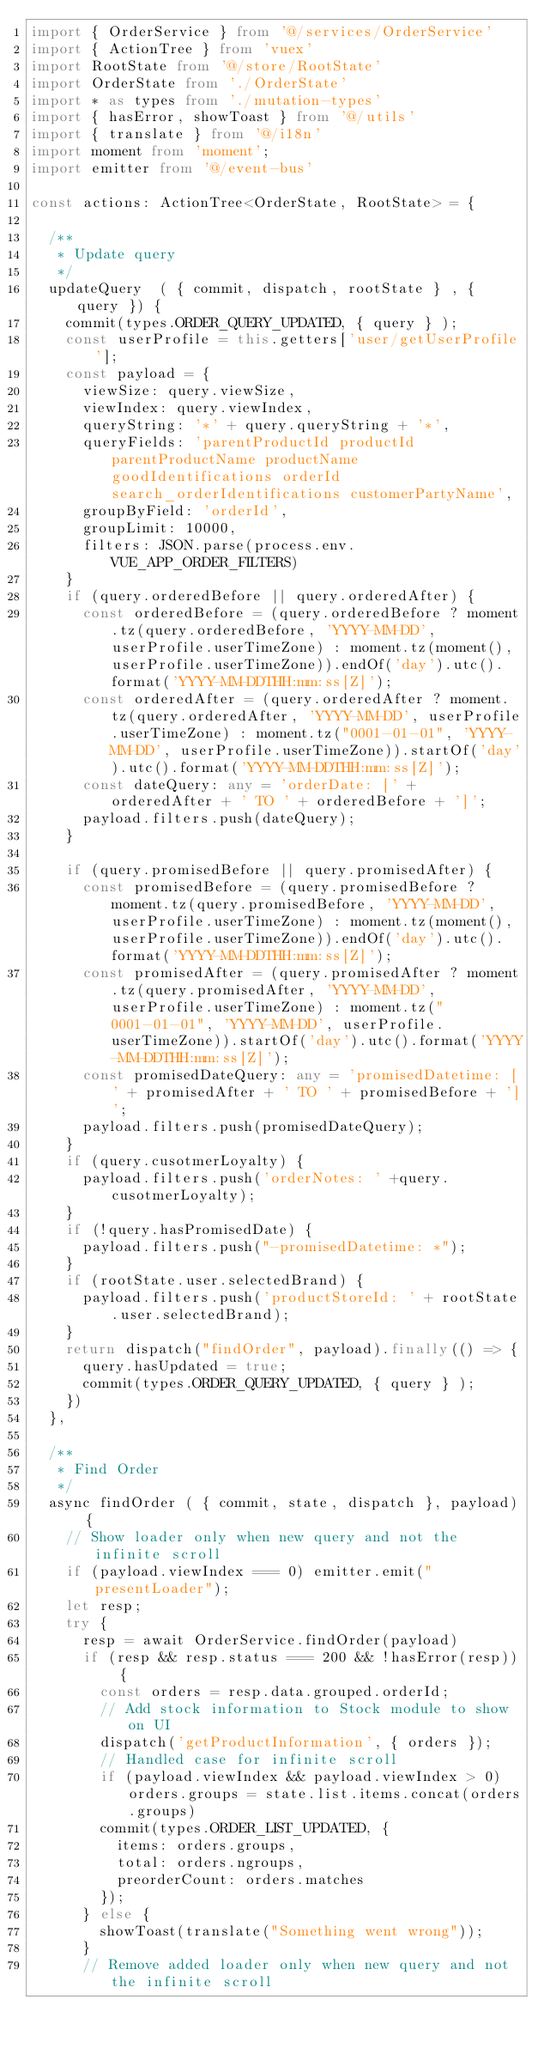<code> <loc_0><loc_0><loc_500><loc_500><_TypeScript_>import { OrderService } from '@/services/OrderService'
import { ActionTree } from 'vuex'
import RootState from '@/store/RootState'
import OrderState from './OrderState'
import * as types from './mutation-types'
import { hasError, showToast } from '@/utils'
import { translate } from '@/i18n'
import moment from 'moment';
import emitter from '@/event-bus'

const actions: ActionTree<OrderState, RootState> = {

  /**
   * Update query
   */
  updateQuery  ( { commit, dispatch, rootState } , { query }) {
    commit(types.ORDER_QUERY_UPDATED, { query } );
    const userProfile = this.getters['user/getUserProfile'];
    const payload = {
      viewSize: query.viewSize,
      viewIndex: query.viewIndex,
      queryString: '*' + query.queryString + '*',
      queryFields: 'parentProductId productId parentProductName productName goodIdentifications orderId search_orderIdentifications customerPartyName',
      groupByField: 'orderId',
      groupLimit: 10000,
      filters: JSON.parse(process.env.VUE_APP_ORDER_FILTERS)
    }
    if (query.orderedBefore || query.orderedAfter) {
      const orderedBefore = (query.orderedBefore ? moment.tz(query.orderedBefore, 'YYYY-MM-DD', userProfile.userTimeZone) : moment.tz(moment(), userProfile.userTimeZone)).endOf('day').utc().format('YYYY-MM-DDTHH:mm:ss[Z]');
      const orderedAfter = (query.orderedAfter ? moment.tz(query.orderedAfter, 'YYYY-MM-DD', userProfile.userTimeZone) : moment.tz("0001-01-01", 'YYYY-MM-DD', userProfile.userTimeZone)).startOf('day').utc().format('YYYY-MM-DDTHH:mm:ss[Z]');
      const dateQuery: any = 'orderDate: [' + orderedAfter + ' TO ' + orderedBefore + ']';
      payload.filters.push(dateQuery);
    }

    if (query.promisedBefore || query.promisedAfter) {
      const promisedBefore = (query.promisedBefore ? moment.tz(query.promisedBefore, 'YYYY-MM-DD', userProfile.userTimeZone) : moment.tz(moment(), userProfile.userTimeZone)).endOf('day').utc().format('YYYY-MM-DDTHH:mm:ss[Z]');
      const promisedAfter = (query.promisedAfter ? moment.tz(query.promisedAfter, 'YYYY-MM-DD', userProfile.userTimeZone) : moment.tz("0001-01-01", 'YYYY-MM-DD', userProfile.userTimeZone)).startOf('day').utc().format('YYYY-MM-DDTHH:mm:ss[Z]');
      const promisedDateQuery: any = 'promisedDatetime: [' + promisedAfter + ' TO ' + promisedBefore + ']';
      payload.filters.push(promisedDateQuery);
    }
    if (query.cusotmerLoyalty) {
      payload.filters.push('orderNotes: ' +query.cusotmerLoyalty);
    }
    if (!query.hasPromisedDate) {
      payload.filters.push("-promisedDatetime: *");
    }
    if (rootState.user.selectedBrand) {
      payload.filters.push('productStoreId: ' + rootState.user.selectedBrand);
    }
    return dispatch("findOrder", payload).finally(() => {
      query.hasUpdated = true;
      commit(types.ORDER_QUERY_UPDATED, { query } );
    })
  },

  /**
   * Find Order
   */
  async findOrder ( { commit, state, dispatch }, payload) {
    // Show loader only when new query and not the infinite scroll
    if (payload.viewIndex === 0) emitter.emit("presentLoader");
    let resp;
    try {
      resp = await OrderService.findOrder(payload)
      if (resp && resp.status === 200 && !hasError(resp)) {
        const orders = resp.data.grouped.orderId;
        // Add stock information to Stock module to show on UI
        dispatch('getProductInformation', { orders });
        // Handled case for infinite scroll
        if (payload.viewIndex && payload.viewIndex > 0) orders.groups = state.list.items.concat(orders.groups)
        commit(types.ORDER_LIST_UPDATED, {
          items: orders.groups,
          total: orders.ngroups,
          preorderCount: orders.matches
        });
      } else {
        showToast(translate("Something went wrong"));
      }
      // Remove added loader only when new query and not the infinite scroll</code> 